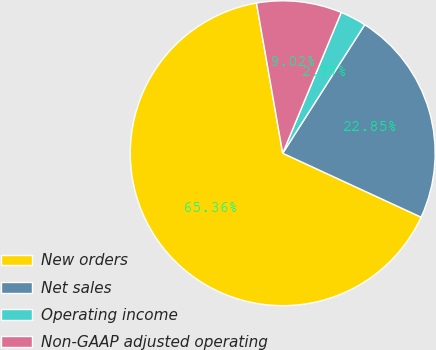Convert chart to OTSL. <chart><loc_0><loc_0><loc_500><loc_500><pie_chart><fcel>New orders<fcel>Net sales<fcel>Operating income<fcel>Non-GAAP adjusted operating<nl><fcel>65.36%<fcel>22.85%<fcel>2.77%<fcel>9.02%<nl></chart> 